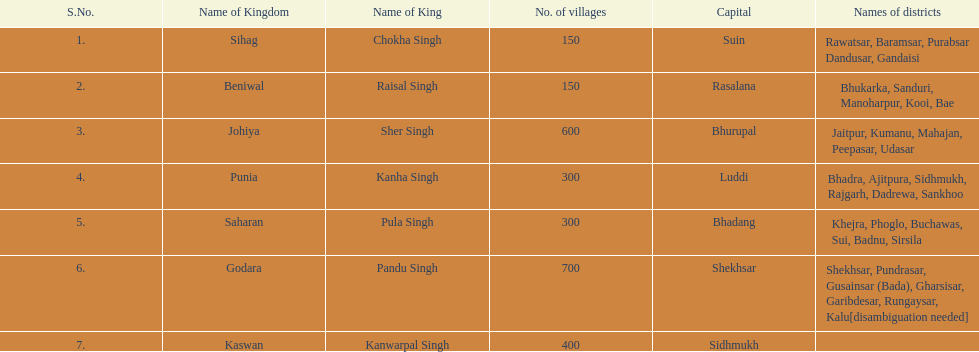What are the number of villages johiya has according to this chart? 600. 